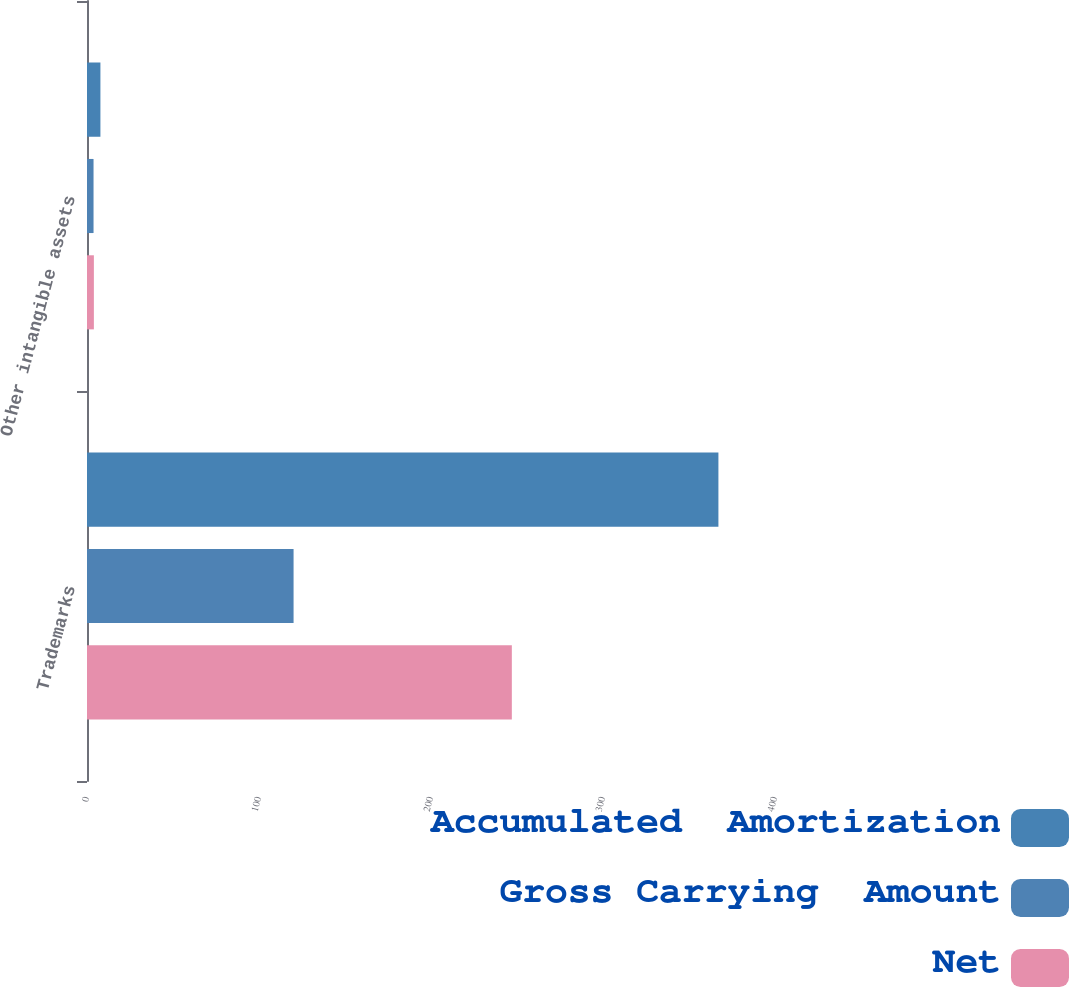Convert chart. <chart><loc_0><loc_0><loc_500><loc_500><stacked_bar_chart><ecel><fcel>Trademarks<fcel>Other intangible assets<nl><fcel>Accumulated  Amortization<fcel>367.1<fcel>7.8<nl><fcel>Gross Carrying  Amount<fcel>120.1<fcel>3.8<nl><fcel>Net<fcel>247<fcel>4<nl></chart> 